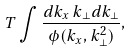Convert formula to latex. <formula><loc_0><loc_0><loc_500><loc_500>T \int \frac { d k _ { x } \, k _ { \perp } d k _ { \perp } } { \phi ( k _ { x } , k _ { \perp } ^ { 2 } ) } ,</formula> 